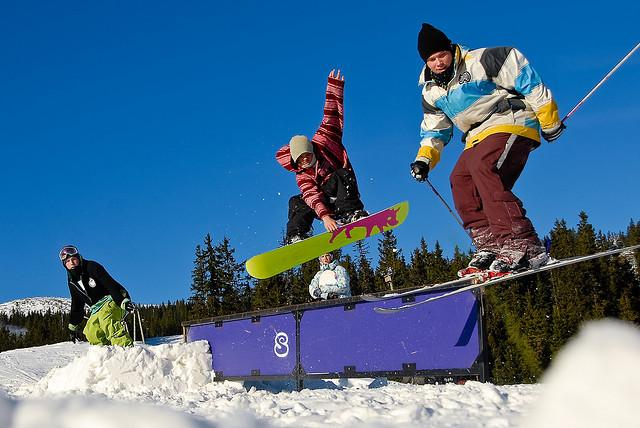What is the black hat the man is wearing called? beanie 